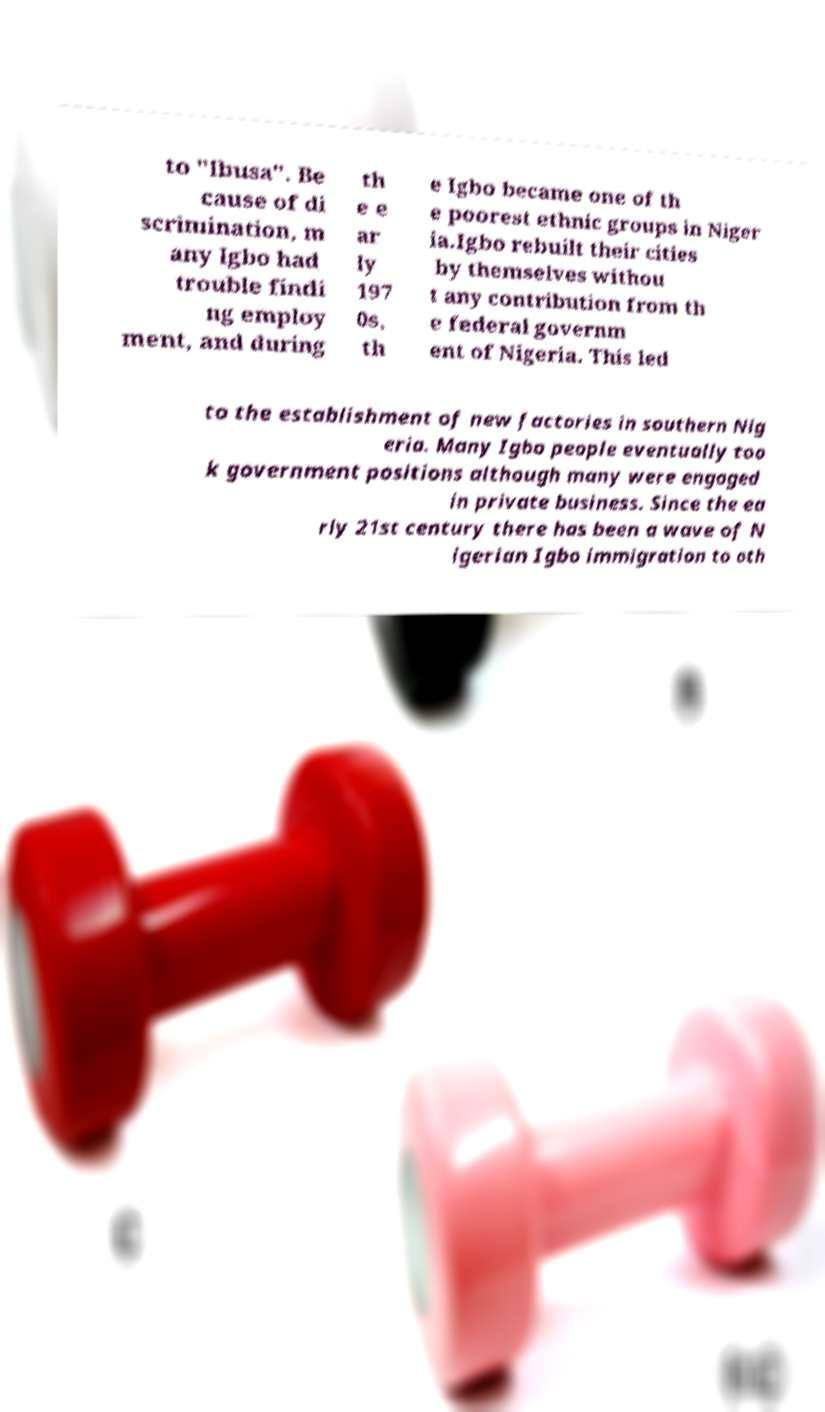Can you accurately transcribe the text from the provided image for me? to "Ibusa". Be cause of di scrimination, m any Igbo had trouble findi ng employ ment, and during th e e ar ly 197 0s, th e Igbo became one of th e poorest ethnic groups in Niger ia.Igbo rebuilt their cities by themselves withou t any contribution from th e federal governm ent of Nigeria. This led to the establishment of new factories in southern Nig eria. Many Igbo people eventually too k government positions although many were engaged in private business. Since the ea rly 21st century there has been a wave of N igerian Igbo immigration to oth 